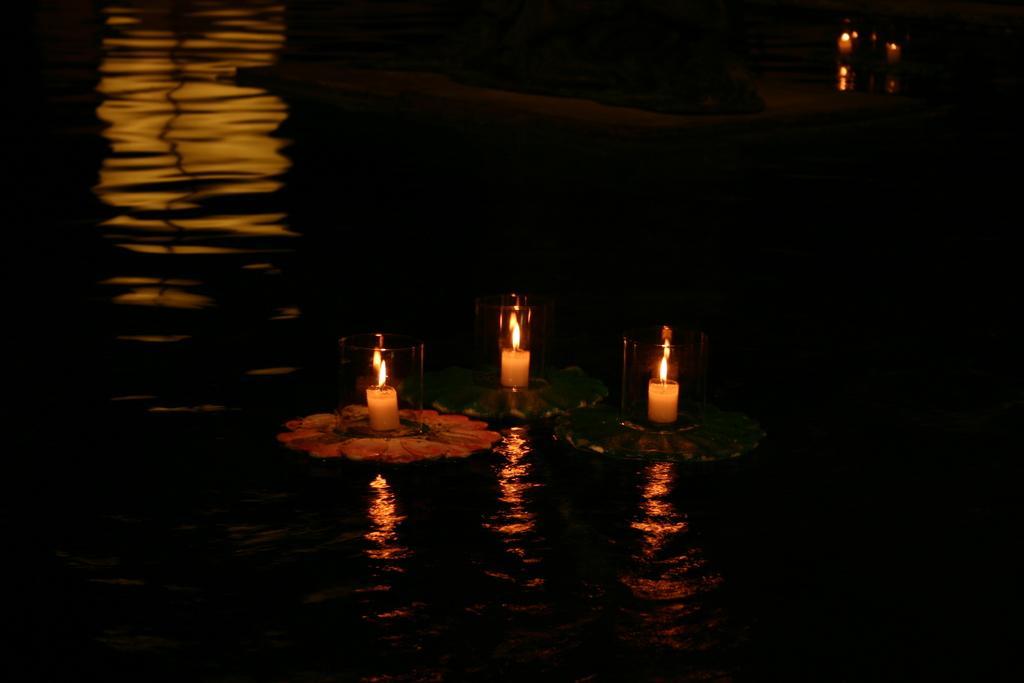Please provide a concise description of this image. In this picture we can see there are candles with flames and the candles are in the glass objects and the candles are on some objects. The objects are on the water. 